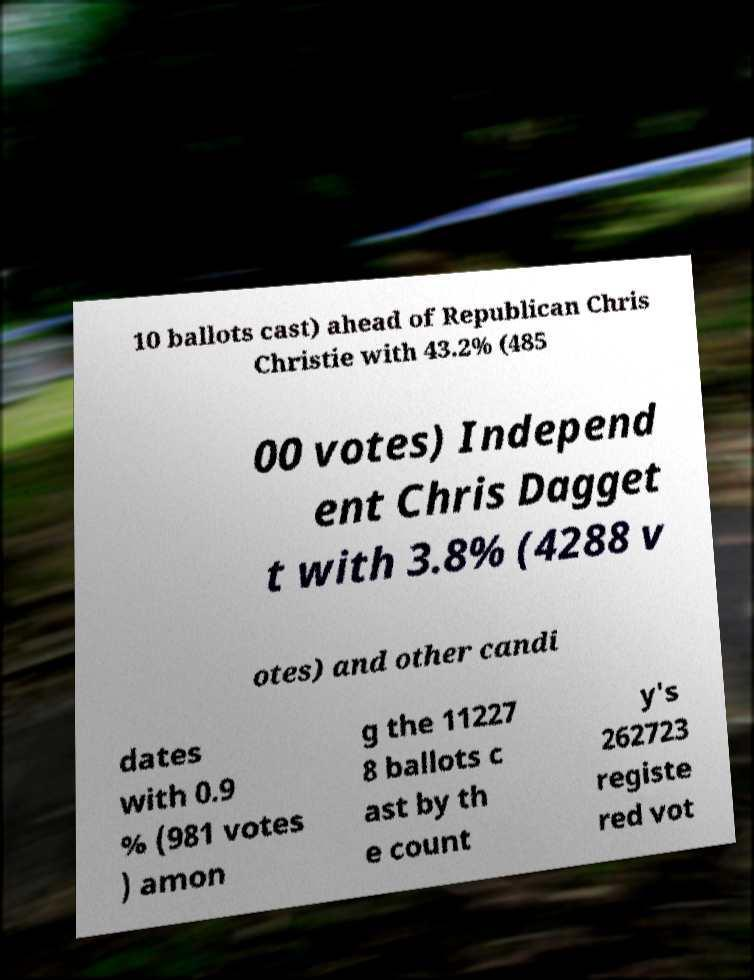What messages or text are displayed in this image? I need them in a readable, typed format. 10 ballots cast) ahead of Republican Chris Christie with 43.2% (485 00 votes) Independ ent Chris Dagget t with 3.8% (4288 v otes) and other candi dates with 0.9 % (981 votes ) amon g the 11227 8 ballots c ast by th e count y's 262723 registe red vot 